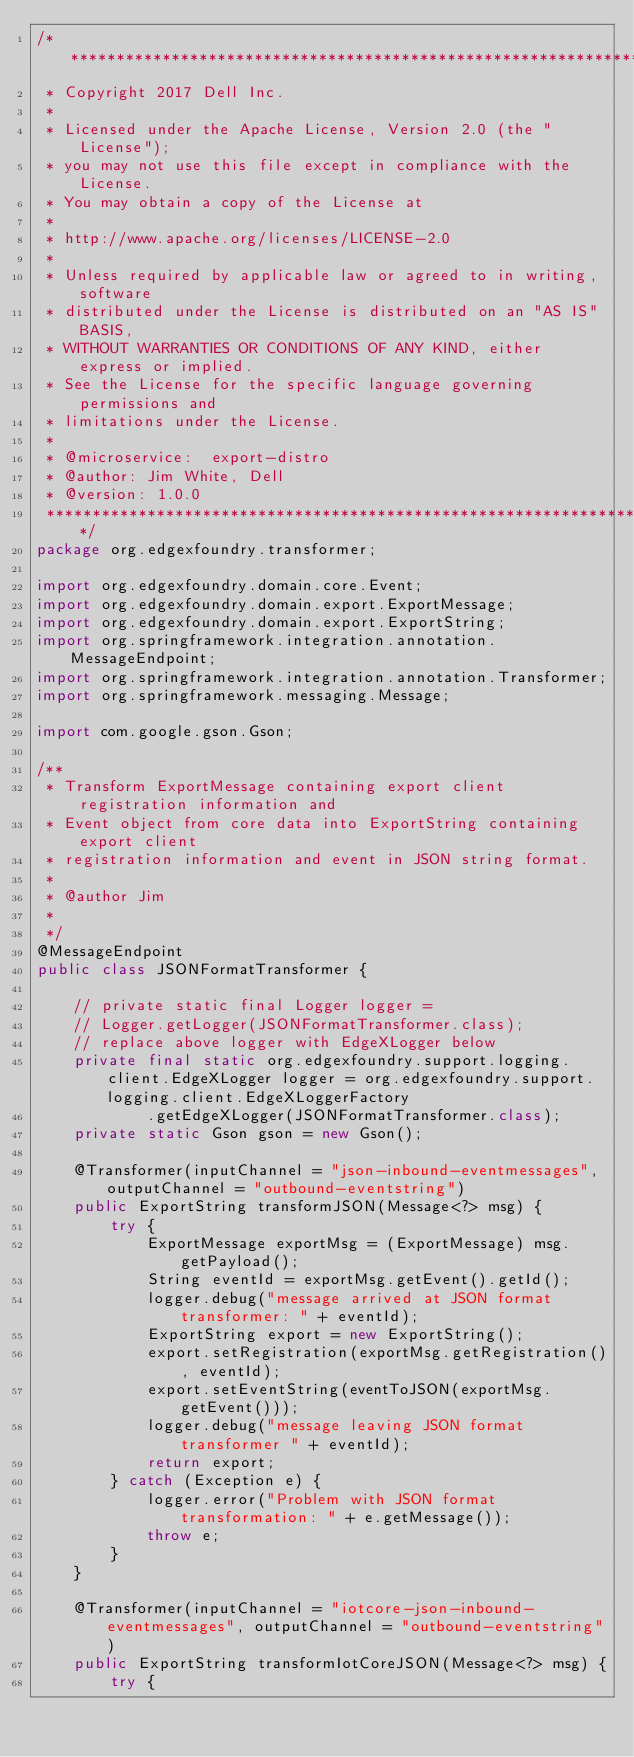<code> <loc_0><loc_0><loc_500><loc_500><_Java_>/*******************************************************************************
 * Copyright 2017 Dell Inc.
 *
 * Licensed under the Apache License, Version 2.0 (the "License");
 * you may not use this file except in compliance with the License.
 * You may obtain a copy of the License at
 *
 * http://www.apache.org/licenses/LICENSE-2.0
 *
 * Unless required by applicable law or agreed to in writing, software
 * distributed under the License is distributed on an "AS IS" BASIS,
 * WITHOUT WARRANTIES OR CONDITIONS OF ANY KIND, either express or implied.
 * See the License for the specific language governing permissions and
 * limitations under the License.
 *
 * @microservice:  export-distro
 * @author: Jim White, Dell
 * @version: 1.0.0
 *******************************************************************************/
package org.edgexfoundry.transformer;

import org.edgexfoundry.domain.core.Event;
import org.edgexfoundry.domain.export.ExportMessage;
import org.edgexfoundry.domain.export.ExportString;
import org.springframework.integration.annotation.MessageEndpoint;
import org.springframework.integration.annotation.Transformer;
import org.springframework.messaging.Message;

import com.google.gson.Gson;

/**
 * Transform ExportMessage containing export client registration information and
 * Event object from core data into ExportString containing export client
 * registration information and event in JSON string format.
 * 
 * @author Jim
 *
 */
@MessageEndpoint
public class JSONFormatTransformer {

	// private static final Logger logger =
	// Logger.getLogger(JSONFormatTransformer.class);
	// replace above logger with EdgeXLogger below
	private final static org.edgexfoundry.support.logging.client.EdgeXLogger logger = org.edgexfoundry.support.logging.client.EdgeXLoggerFactory
			.getEdgeXLogger(JSONFormatTransformer.class);
	private static Gson gson = new Gson();

	@Transformer(inputChannel = "json-inbound-eventmessages", outputChannel = "outbound-eventstring")
	public ExportString transformJSON(Message<?> msg) {
		try {
			ExportMessage exportMsg = (ExportMessage) msg.getPayload();
			String eventId = exportMsg.getEvent().getId();
			logger.debug("message arrived at JSON format transformer: " + eventId);
			ExportString export = new ExportString();
			export.setRegistration(exportMsg.getRegistration(), eventId);
			export.setEventString(eventToJSON(exportMsg.getEvent()));
			logger.debug("message leaving JSON format transformer " + eventId);
			return export;
		} catch (Exception e) {
			logger.error("Problem with JSON format transformation: " + e.getMessage());
			throw e;
		}
	}

	@Transformer(inputChannel = "iotcore-json-inbound-eventmessages", outputChannel = "outbound-eventstring")
	public ExportString transformIotCoreJSON(Message<?> msg) {
		try {</code> 